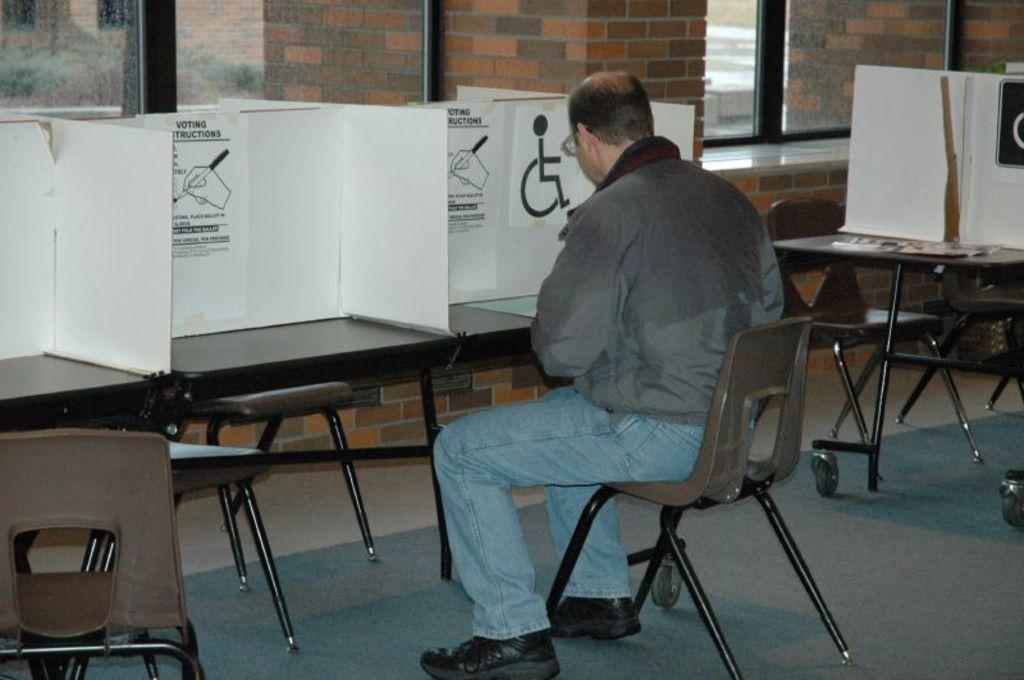How would you summarize this image in a sentence or two? In this image we can see a man is sitting on the chair, and in front here is the table and some objects on it, and here is the wall made of bricks, and here is the window. 